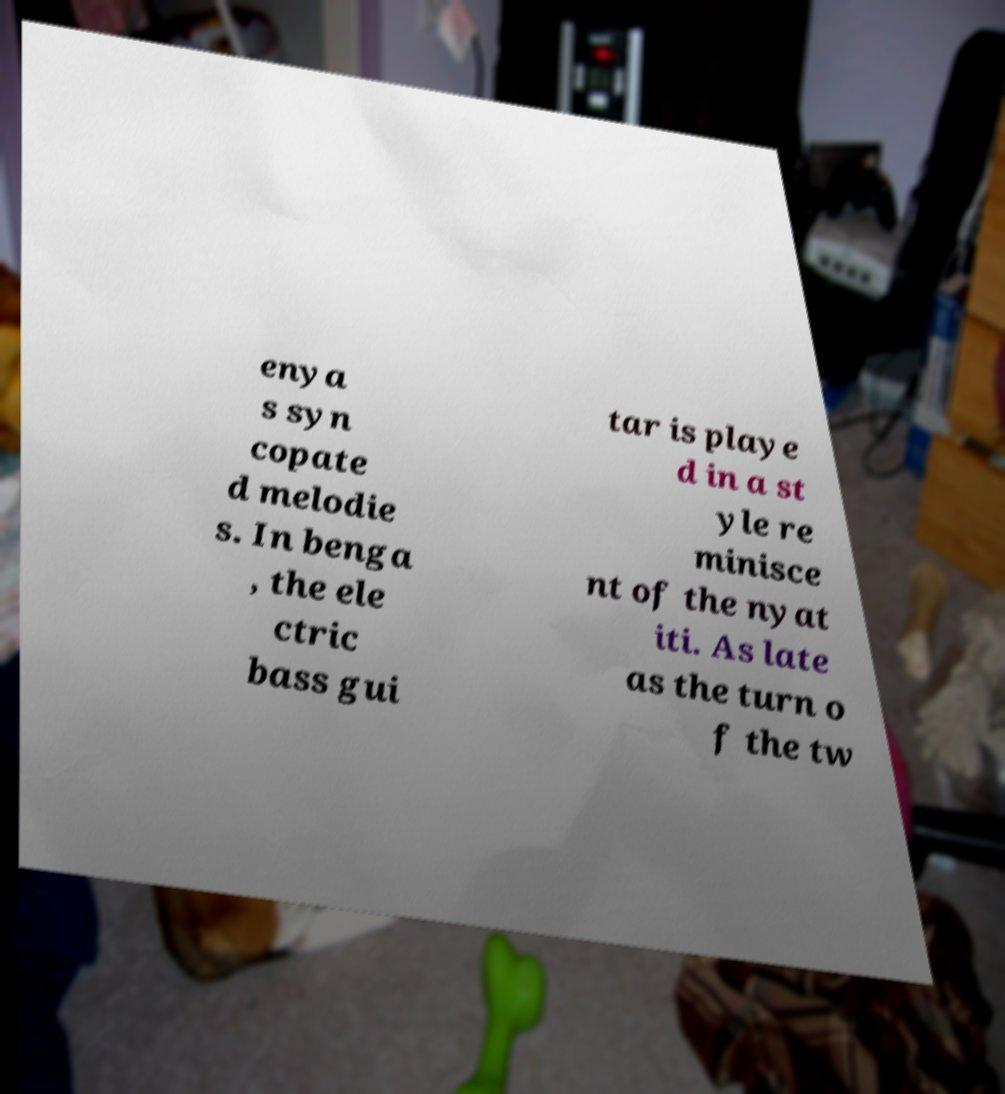For documentation purposes, I need the text within this image transcribed. Could you provide that? enya s syn copate d melodie s. In benga , the ele ctric bass gui tar is playe d in a st yle re minisce nt of the nyat iti. As late as the turn o f the tw 